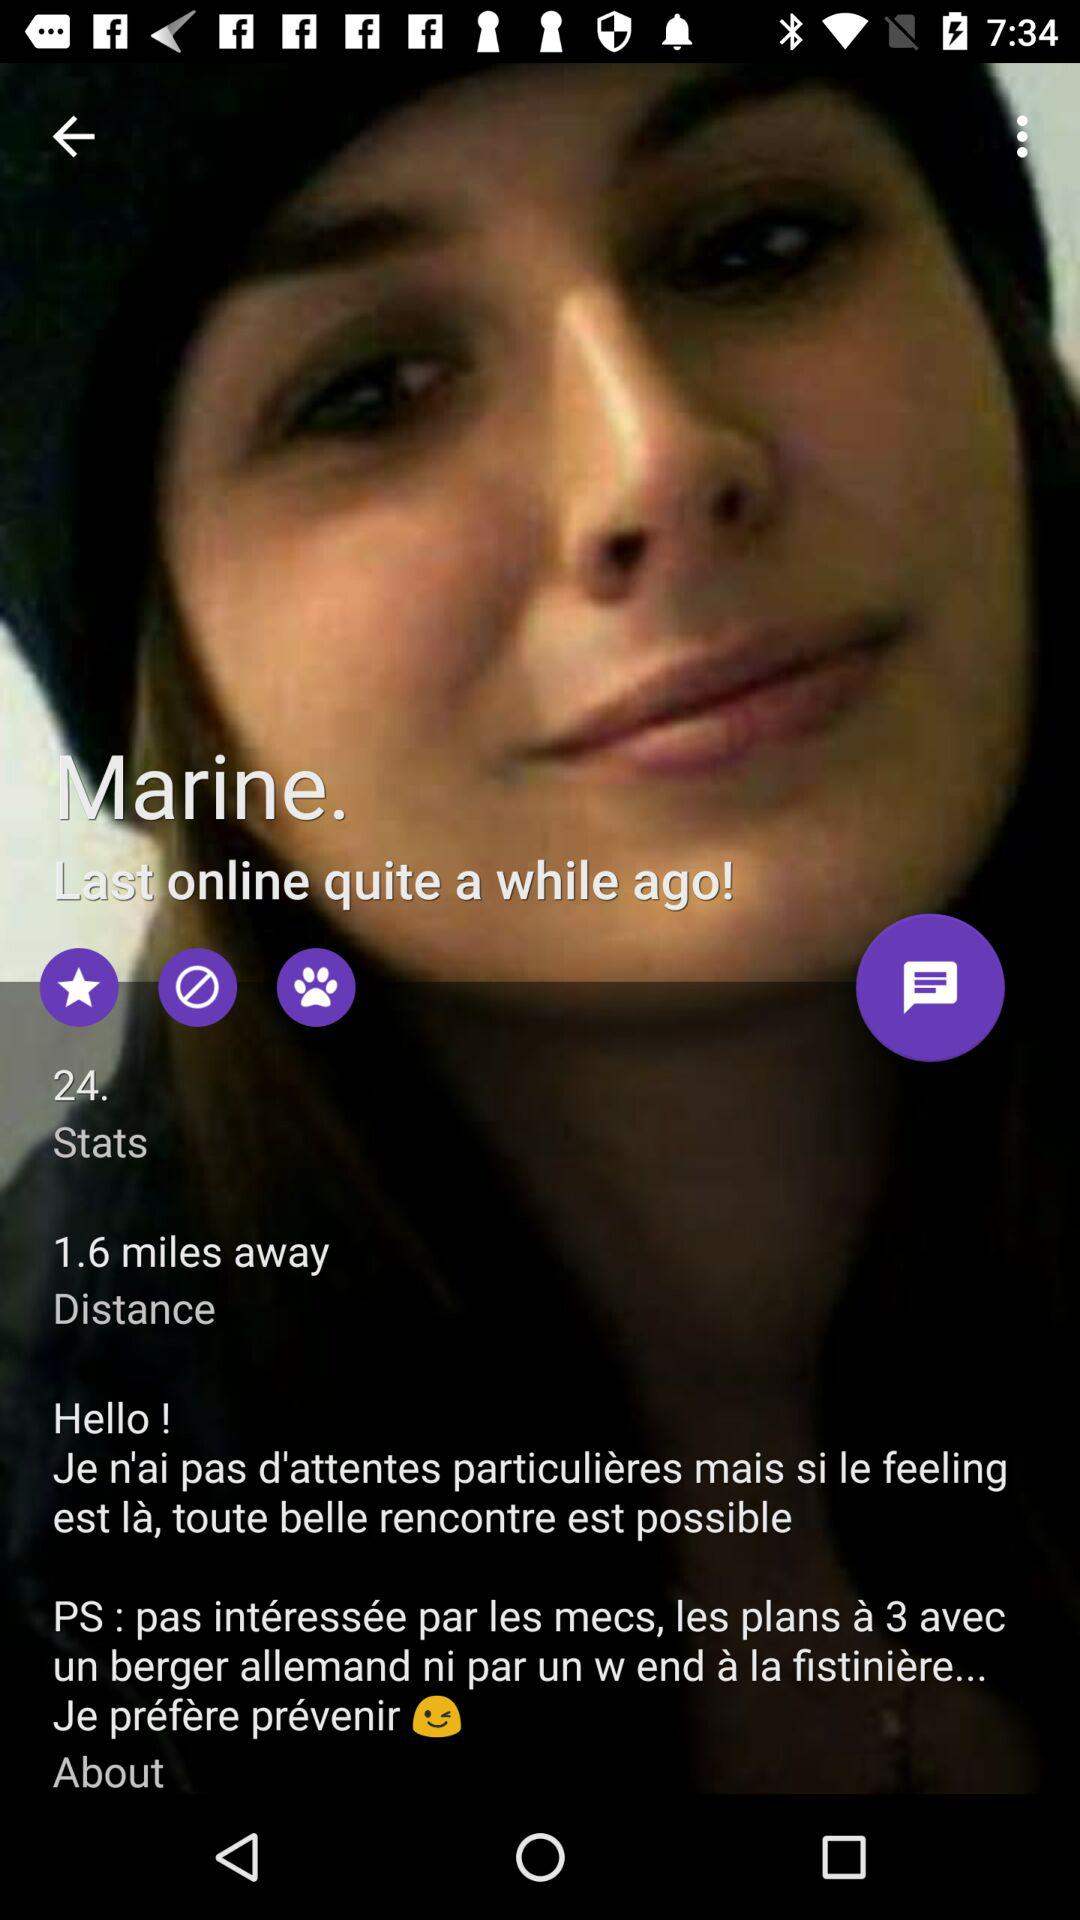What is the distance? The distance is 1.6 miles. 